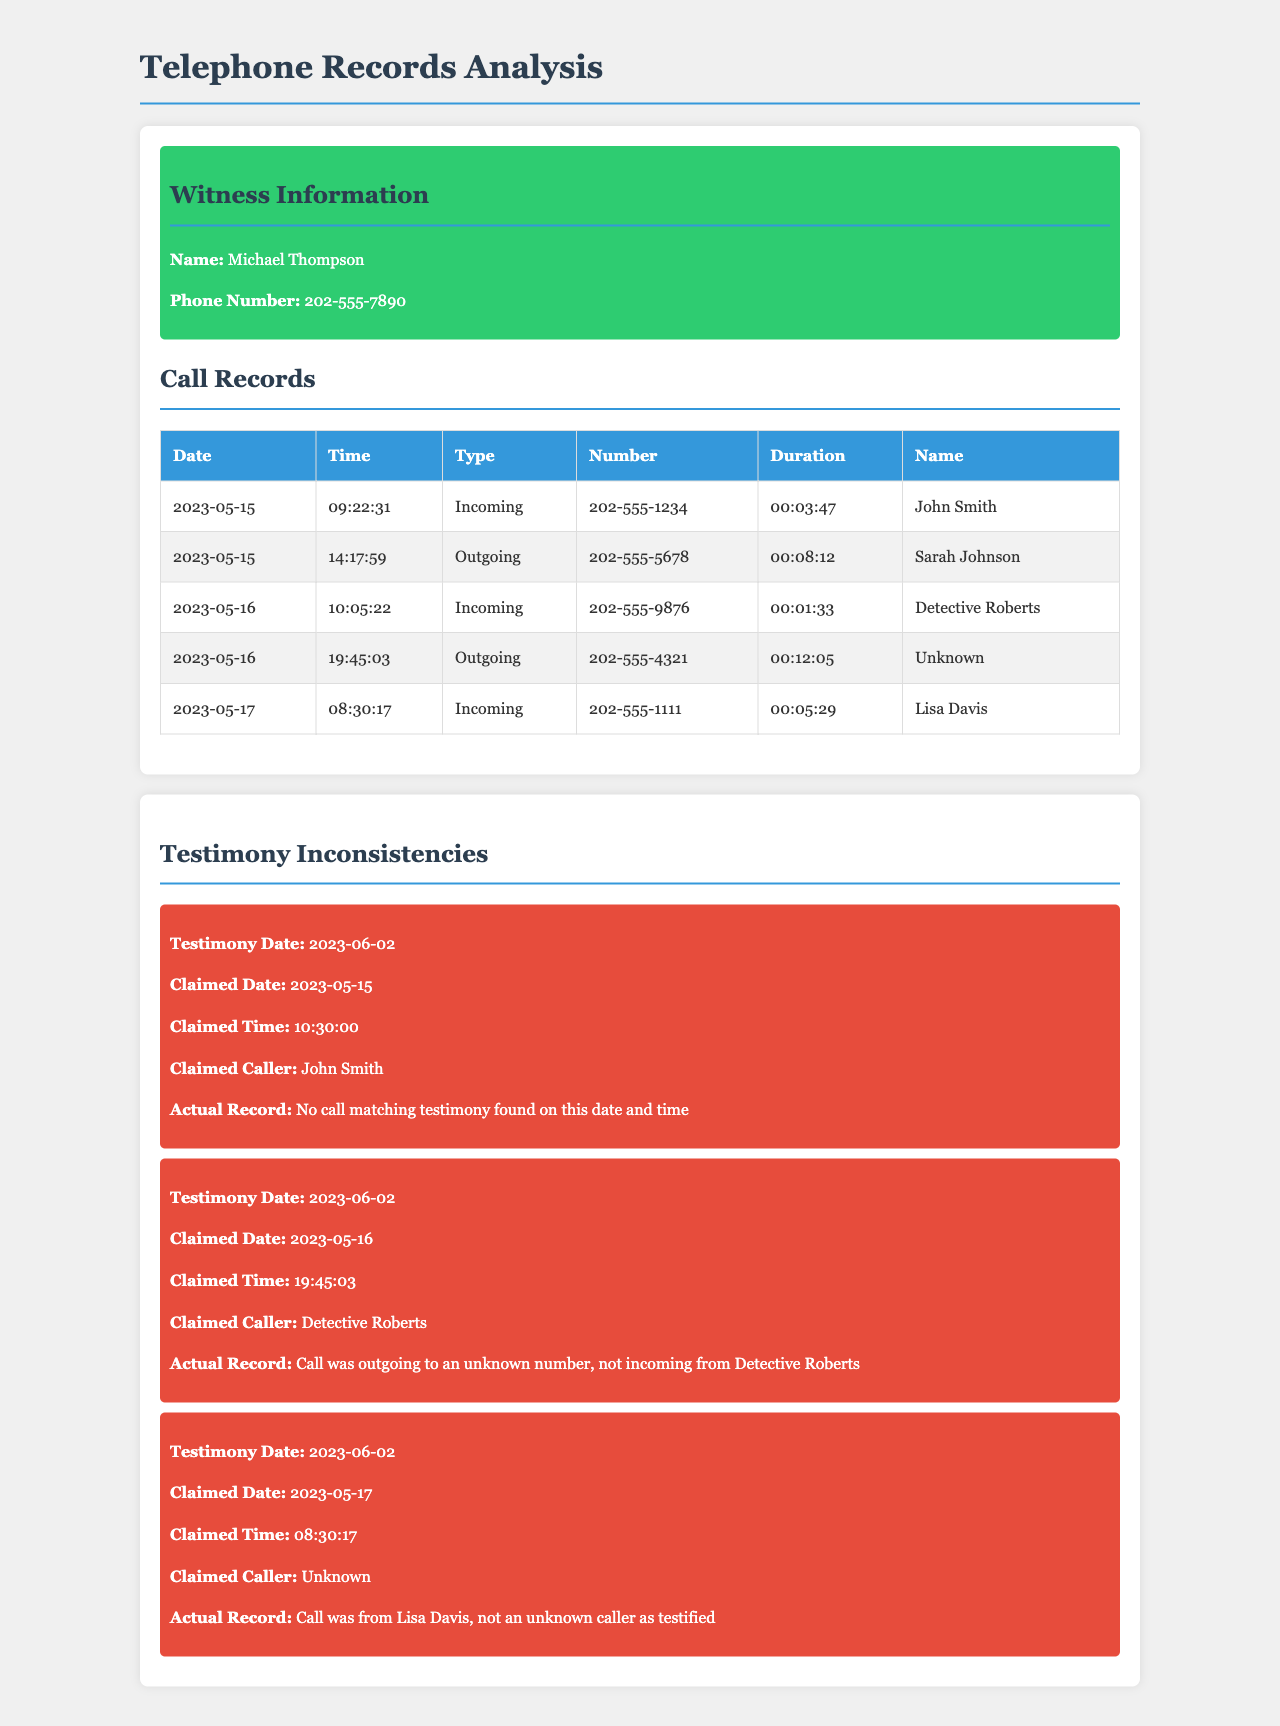What is the name of the witness? The document provides the witness's name in the witness information section, which is prominently displayed.
Answer: Michael Thompson What is the phone number of the witness? The phone number is listed in the witness information section, providing contact details for the witness.
Answer: 202-555-7890 How many incoming calls were recorded on May 15, 2023? The number of incoming calls can be counted in the call records table for that specific date.
Answer: 1 Who was the caller on the outgoing call on May 16, 2023? The name of the caller is provided in the call records under the outgoing call on that specific date.
Answer: Unknown What time was the incoming call from Detective Roberts? The time of the call can be found in the call records table under the row for the incoming call noted for that date.
Answer: 10:05:22 What is the claimed caller for the testimony on May 16, 2023? The claimed caller is listed in the testimony inconsistencies section to compare against the actual records.
Answer: Detective Roberts What was the duration of the incoming call from Lisa Davis? The call duration is stated in the call records table for the incoming call from that specific individual.
Answer: 00:05:29 How many inconsistencies are noted in the testimony analysis? The number of inconsistencies can be counted from the section discussing testimony inconsistencies, which provides insight into specific discrepancies.
Answer: 3 What was the actual record for the call claimed on May 17, 2023? The actual record details are provided in the inconsistency section related to the claimed call for that date.
Answer: Call was from Lisa Davis, not an unknown caller as testified 